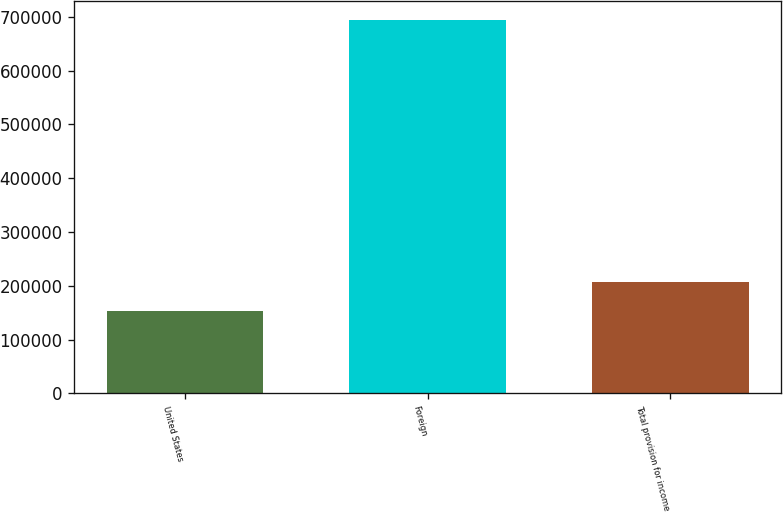<chart> <loc_0><loc_0><loc_500><loc_500><bar_chart><fcel>United States<fcel>Foreign<fcel>Total provision for income<nl><fcel>152851<fcel>693794<fcel>207896<nl></chart> 